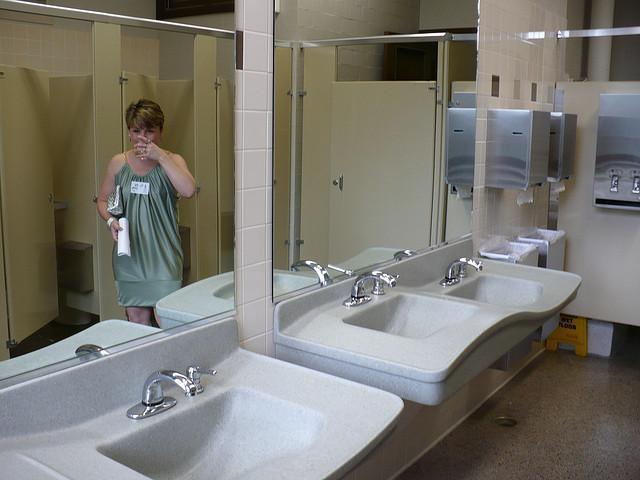What is the woman wearing?
Answer the question by selecting the correct answer among the 4 following choices.
Options: Dress, dress, jeans, pyjamas. Dress. 